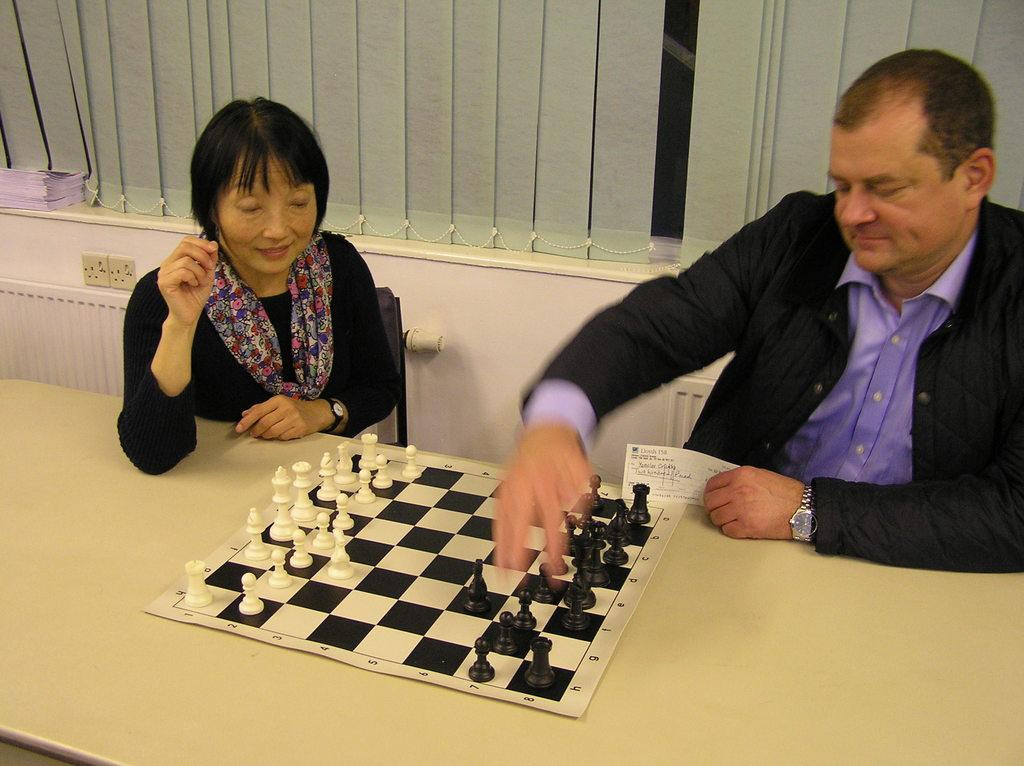What can be seen in the image that provides a view of the outside? There is a window in the image that provides a view of the outside. What are the two people in the image doing? The two people in the image are sitting on chairs. What is on the table in the image? There is a chess board and coins on the table. Can you see a list of items on the table in the image? There is no list of items present on the table in the image. Is there a seashore visible through the window in the image? The image does not show a seashore; it only shows a window that provides a view of the outside. Is there a frog sitting on the chess board in the image? There is no frog present on the chess board or anywhere else in the image. 